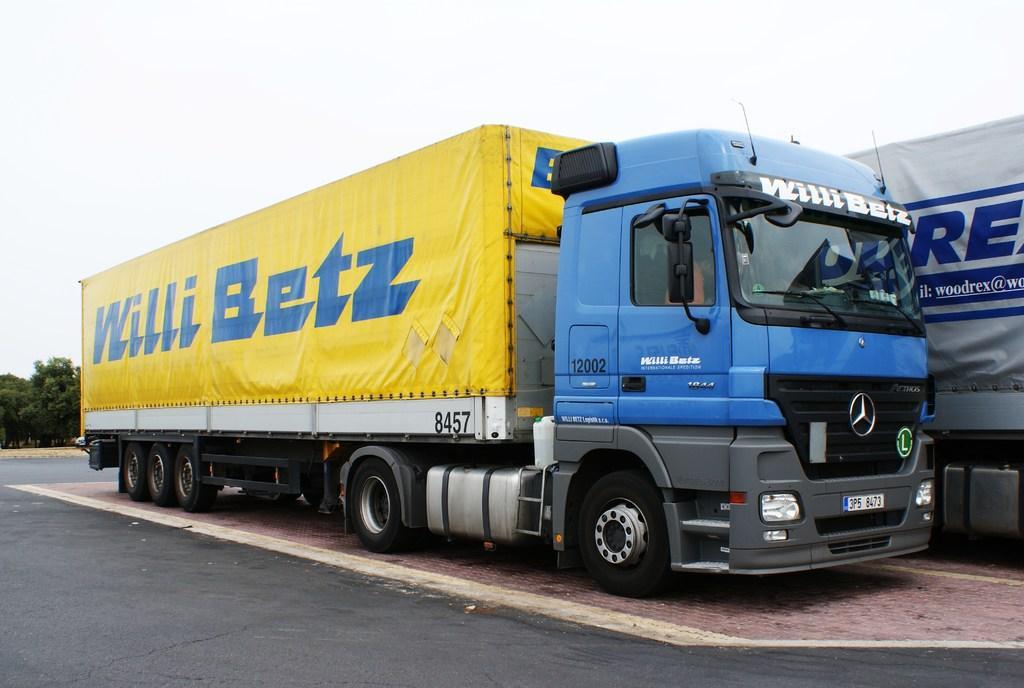In one or two sentences, can you explain what this image depicts? In this picture we can see couple of trucks on the road, in the background we can see trees. 